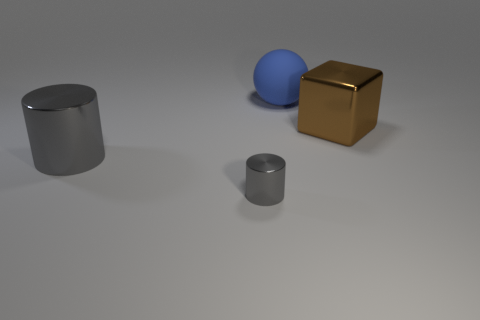Is there a big brown matte thing?
Provide a short and direct response. No. There is a cube; is its color the same as the big object on the left side of the large ball?
Keep it short and to the point. No. There is a thing that is the same color as the big cylinder; what is it made of?
Offer a terse response. Metal. Is there any other thing that is the same shape as the large brown thing?
Offer a very short reply. No. There is a gray shiny object that is behind the gray shiny object in front of the big thing in front of the big brown object; what is its shape?
Give a very brief answer. Cylinder. What is the shape of the blue object?
Offer a terse response. Sphere. The shiny thing right of the tiny cylinder is what color?
Provide a succinct answer. Brown. Does the object that is behind the brown shiny cube have the same size as the big gray cylinder?
Your answer should be very brief. Yes. What size is the other gray thing that is the same shape as the small gray metallic object?
Offer a very short reply. Large. Is there anything else that has the same size as the blue matte object?
Ensure brevity in your answer.  Yes. 